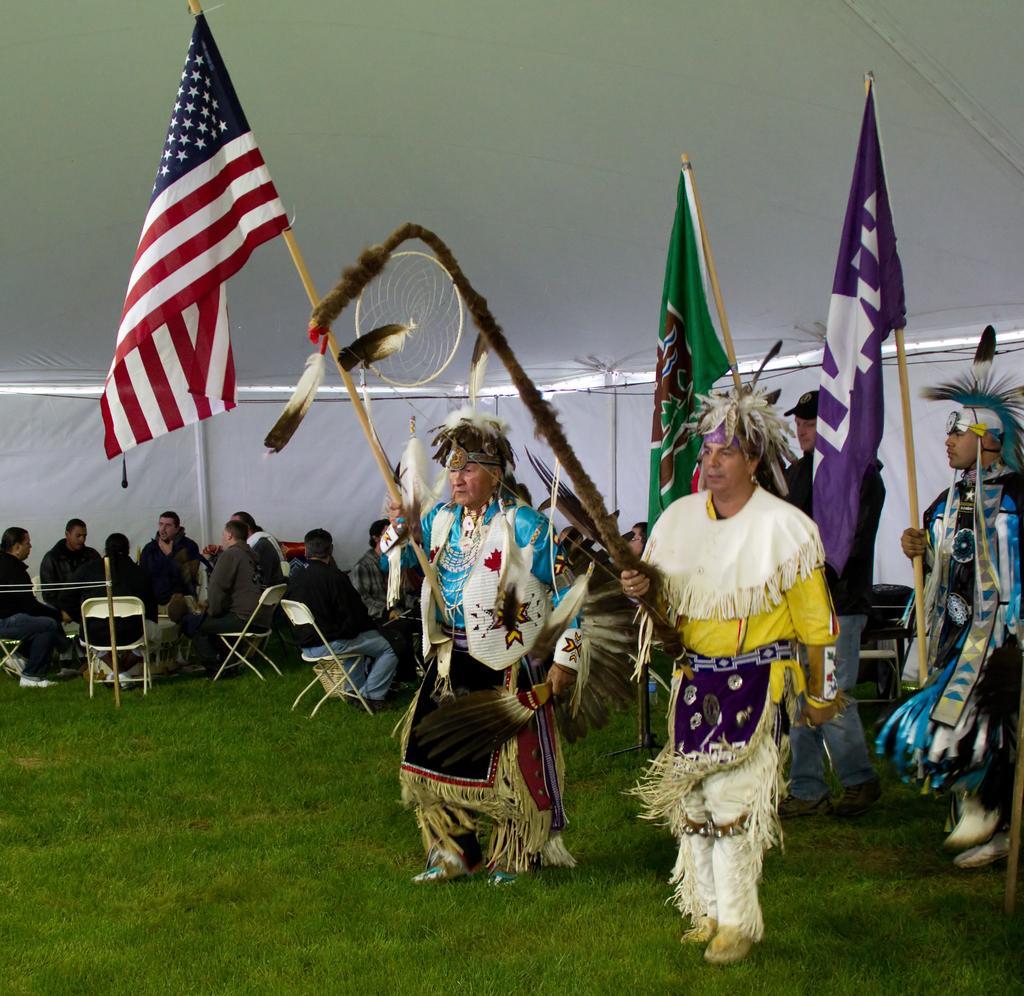Please provide a concise description of this image. In the foreground of the picture there are four people and grass. The people are holding flags. In the background there are people and the chairs. At the top it is tent. 